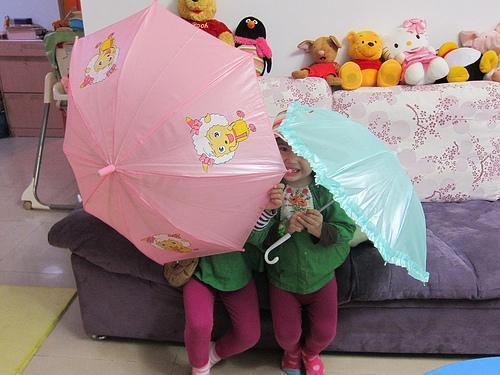How many people are there?
Give a very brief answer. 2. 